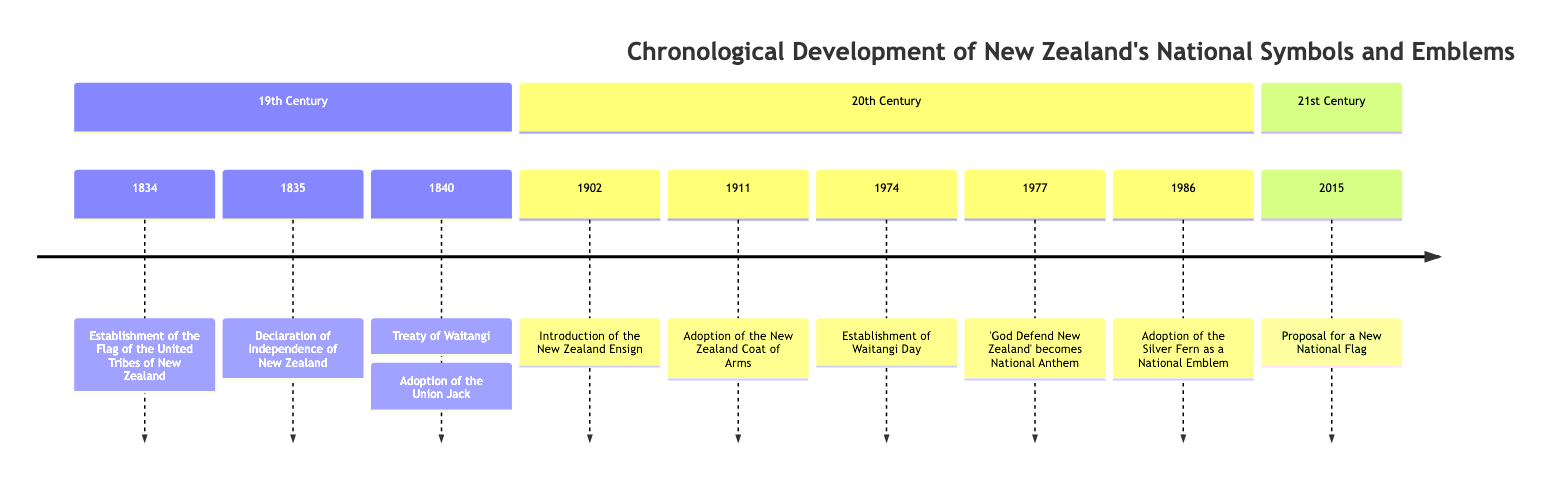What year was the Flag of the United Tribes of New Zealand established? The diagram shows that the establishment of the Flag of the United Tribes of New Zealand occurred in the year 1834.
Answer: 1834 What event immediately follows the Declaration of Independence of New Zealand on the timeline? The timeline indicates that the Declaration of Independence of New Zealand in 1835 is followed by the Treaty of Waitangi in 1840.
Answer: Treaty of Waitangi How many events are depicted in the 19th Century section? By counting the nodes listed in the 19th Century section of the timeline, there are four events: the establishment of the flag, declaration of independence, treaty, and adoption of the Union Jack.
Answer: 4 What is the date of the adoption of the New Zealand Coat of Arms? The adoption of the New Zealand Coat of Arms is listed in the diagram as occurring in 1911.
Answer: 1911 Which symbol was officially recognized in 1986? According to the diagram, the Silver Fern was officially recognized as a national emblem in the year 1986.
Answer: Silver Fern What notable event related to national identity happened in 1840? The diagram indicates that both the Treaty of Waitangi and the adoption of the Union Jack are significant events related to national identity that occurred in 1840.
Answer: Treaty of Waitangi What was proposed in 2015 according to the timeline? In 2015, the timeline states that there was a proposal for a New National Flag.
Answer: Proposal for a New National Flag Which national symbol was adopted alongside 'God Save the Queen'? The diagram notes that 'God Defend New Zealand' was adopted as a national anthem alongside 'God Save the Queen'.
Answer: God Defend New Zealand What section contains the majority of events? By examining the timeline, the 20th Century section contains the majority of events relating to national symbols and emblems, with five entries compared to the others.
Answer: 20th Century 